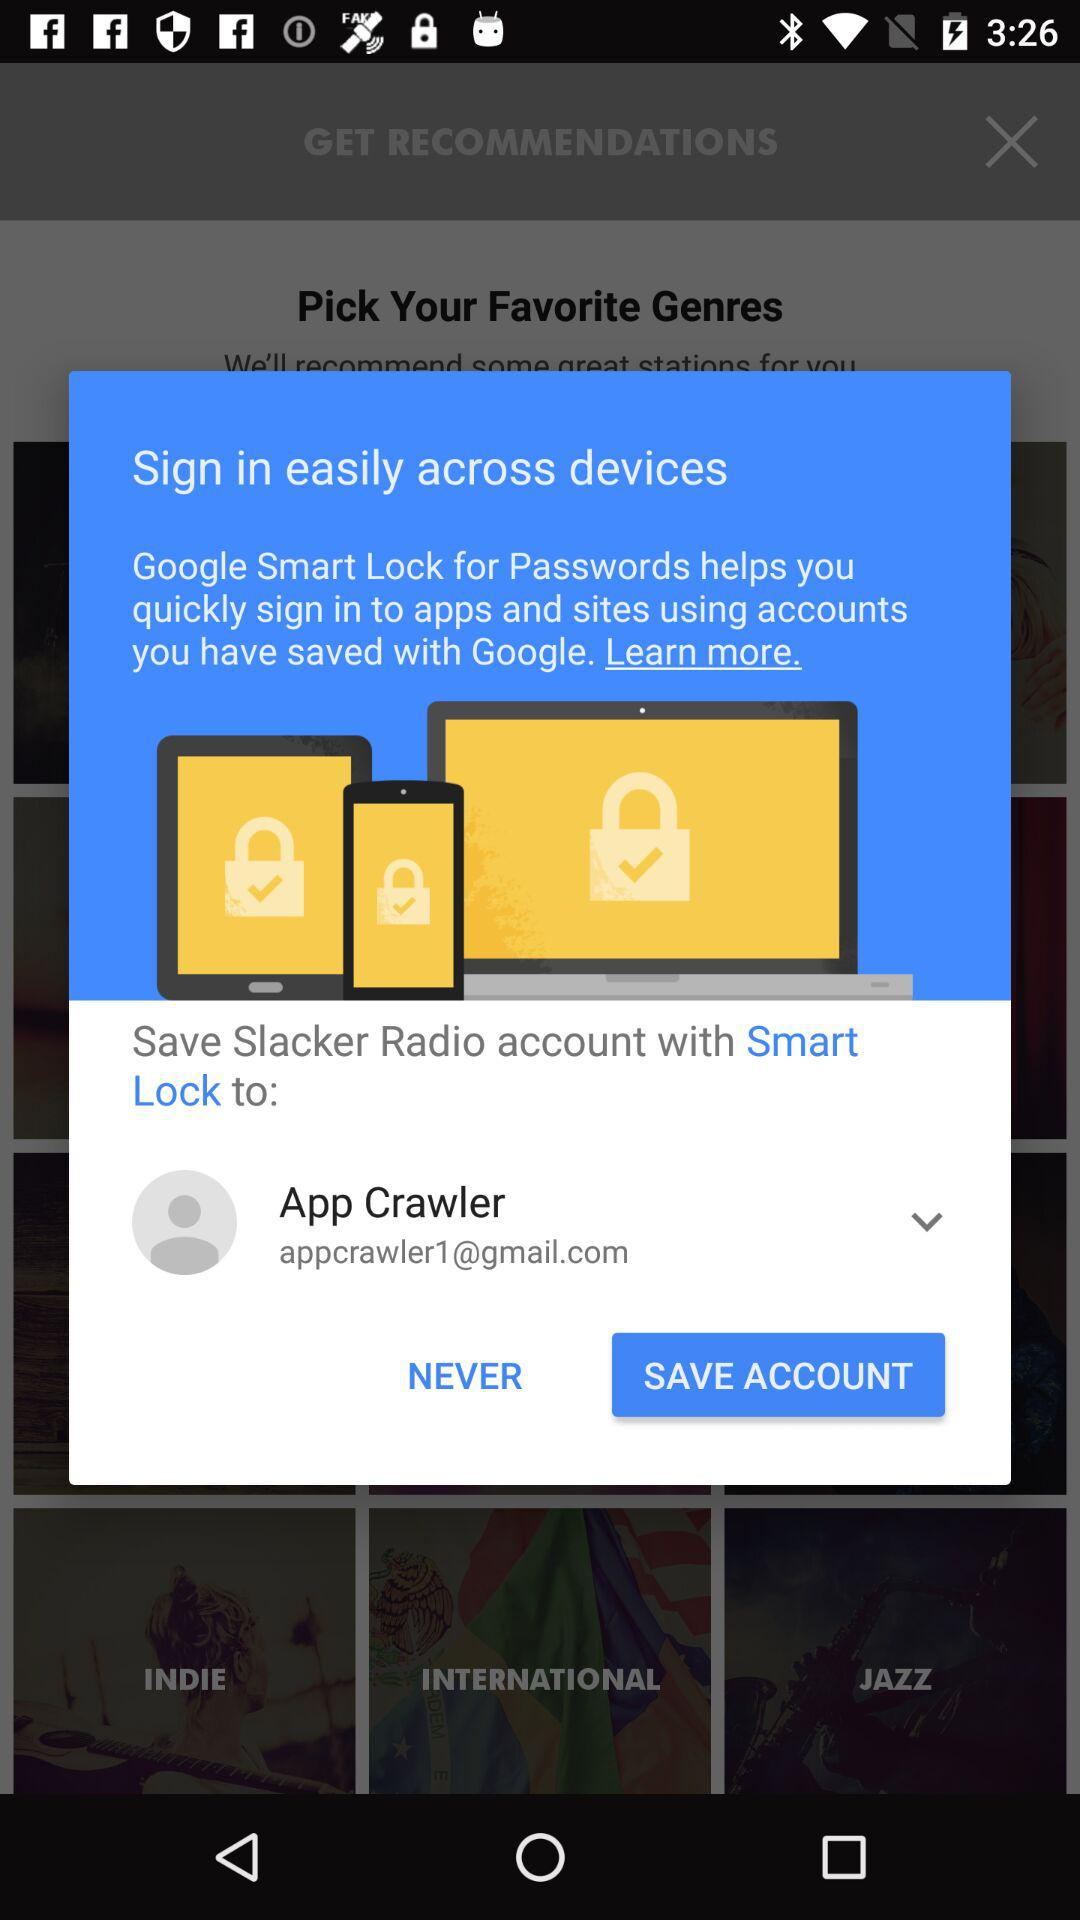What is the given email address? The given email address is appcrawler1@gmail.com. 